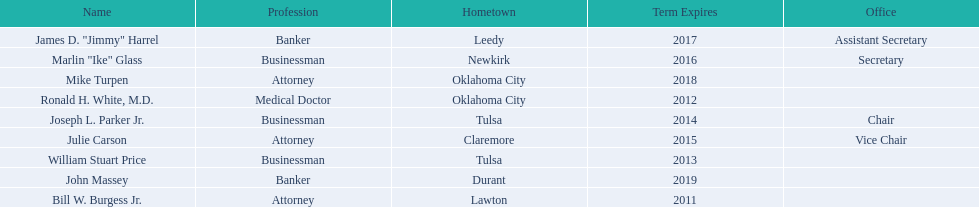Who are the businessmen? Bill W. Burgess Jr., Ronald H. White, M.D., William Stuart Price, Joseph L. Parker Jr., Julie Carson, Marlin "Ike" Glass, James D. "Jimmy" Harrel, Mike Turpen, John Massey. Which were born in tulsa? William Stuart Price, Joseph L. Parker Jr. Of these, which one was other than william stuart price? Joseph L. Parker Jr. 